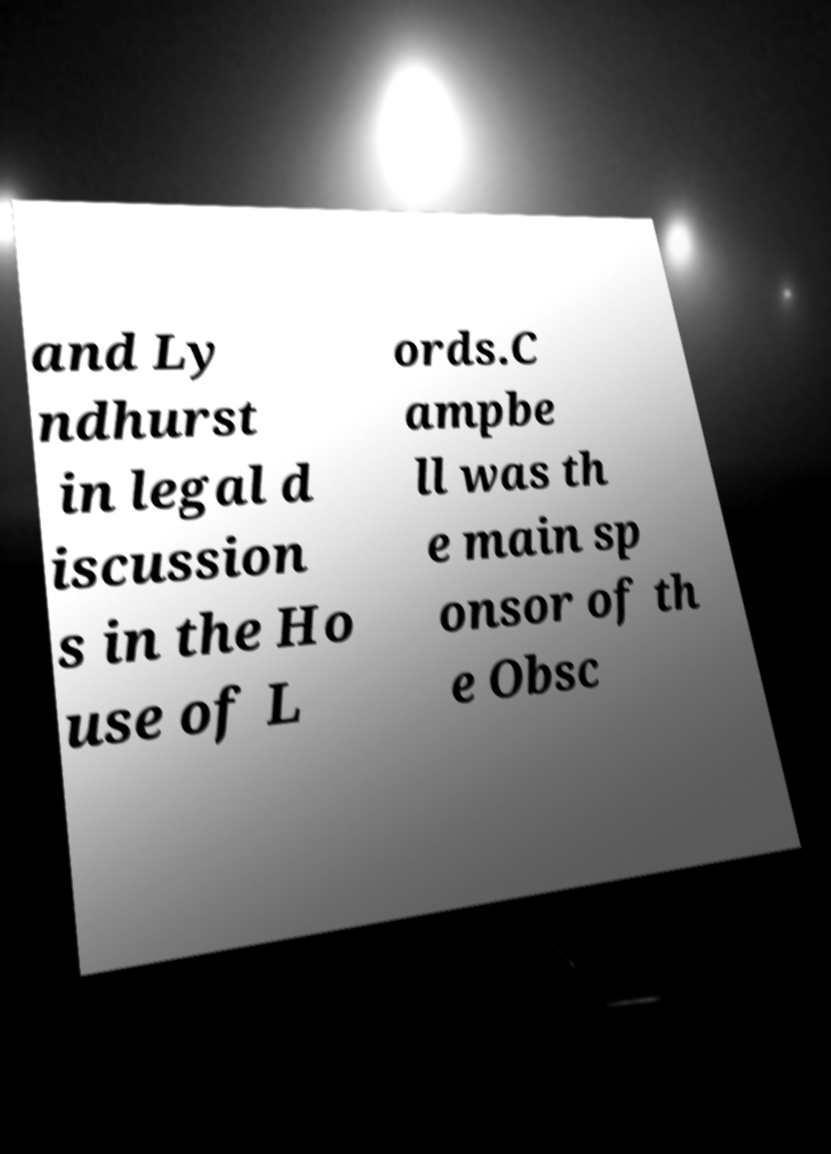For documentation purposes, I need the text within this image transcribed. Could you provide that? and Ly ndhurst in legal d iscussion s in the Ho use of L ords.C ampbe ll was th e main sp onsor of th e Obsc 